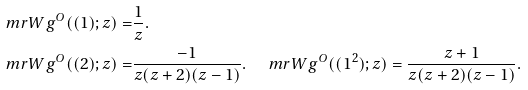Convert formula to latex. <formula><loc_0><loc_0><loc_500><loc_500>\ m r { W g } ^ { O } ( ( 1 ) ; z ) = & \frac { 1 } { z } . \\ \ m r { W g } ^ { O } ( ( 2 ) ; z ) = & \frac { - 1 } { z ( z + 2 ) ( z - 1 ) } . \quad \ m r { W g } ^ { O } ( ( 1 ^ { 2 } ) ; z ) = \frac { z + 1 } { z ( z + 2 ) ( z - 1 ) } .</formula> 